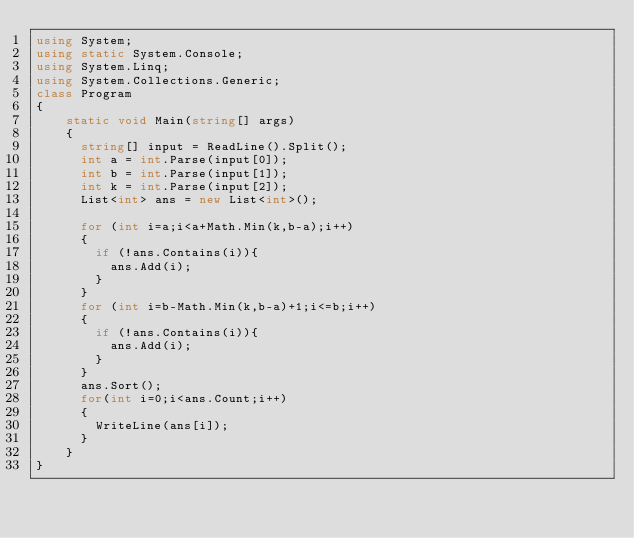<code> <loc_0><loc_0><loc_500><loc_500><_C#_>using System;
using static System.Console;
using System.Linq;
using System.Collections.Generic;
class Program
{
    static void Main(string[] args)
    {
      string[] input = ReadLine().Split();
      int a = int.Parse(input[0]);
      int b = int.Parse(input[1]);
      int k = int.Parse(input[2]);
      List<int> ans = new List<int>();
      
      for (int i=a;i<a+Math.Min(k,b-a);i++)
      {
        if (!ans.Contains(i)){
          ans.Add(i);
        }
      }
      for (int i=b-Math.Min(k,b-a)+1;i<=b;i++)
      {
        if (!ans.Contains(i)){
          ans.Add(i);
        }
      }
      ans.Sort();
      for(int i=0;i<ans.Count;i++)
      {
        WriteLine(ans[i]);
      }
    }
}</code> 